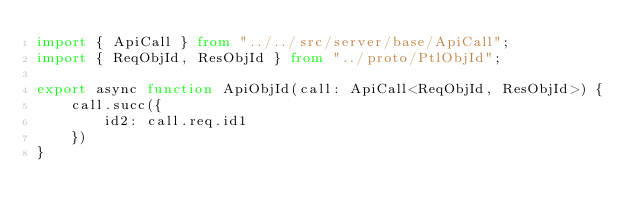<code> <loc_0><loc_0><loc_500><loc_500><_TypeScript_>import { ApiCall } from "../../src/server/base/ApiCall";
import { ReqObjId, ResObjId } from "../proto/PtlObjId";

export async function ApiObjId(call: ApiCall<ReqObjId, ResObjId>) {
    call.succ({
        id2: call.req.id1
    })
}</code> 